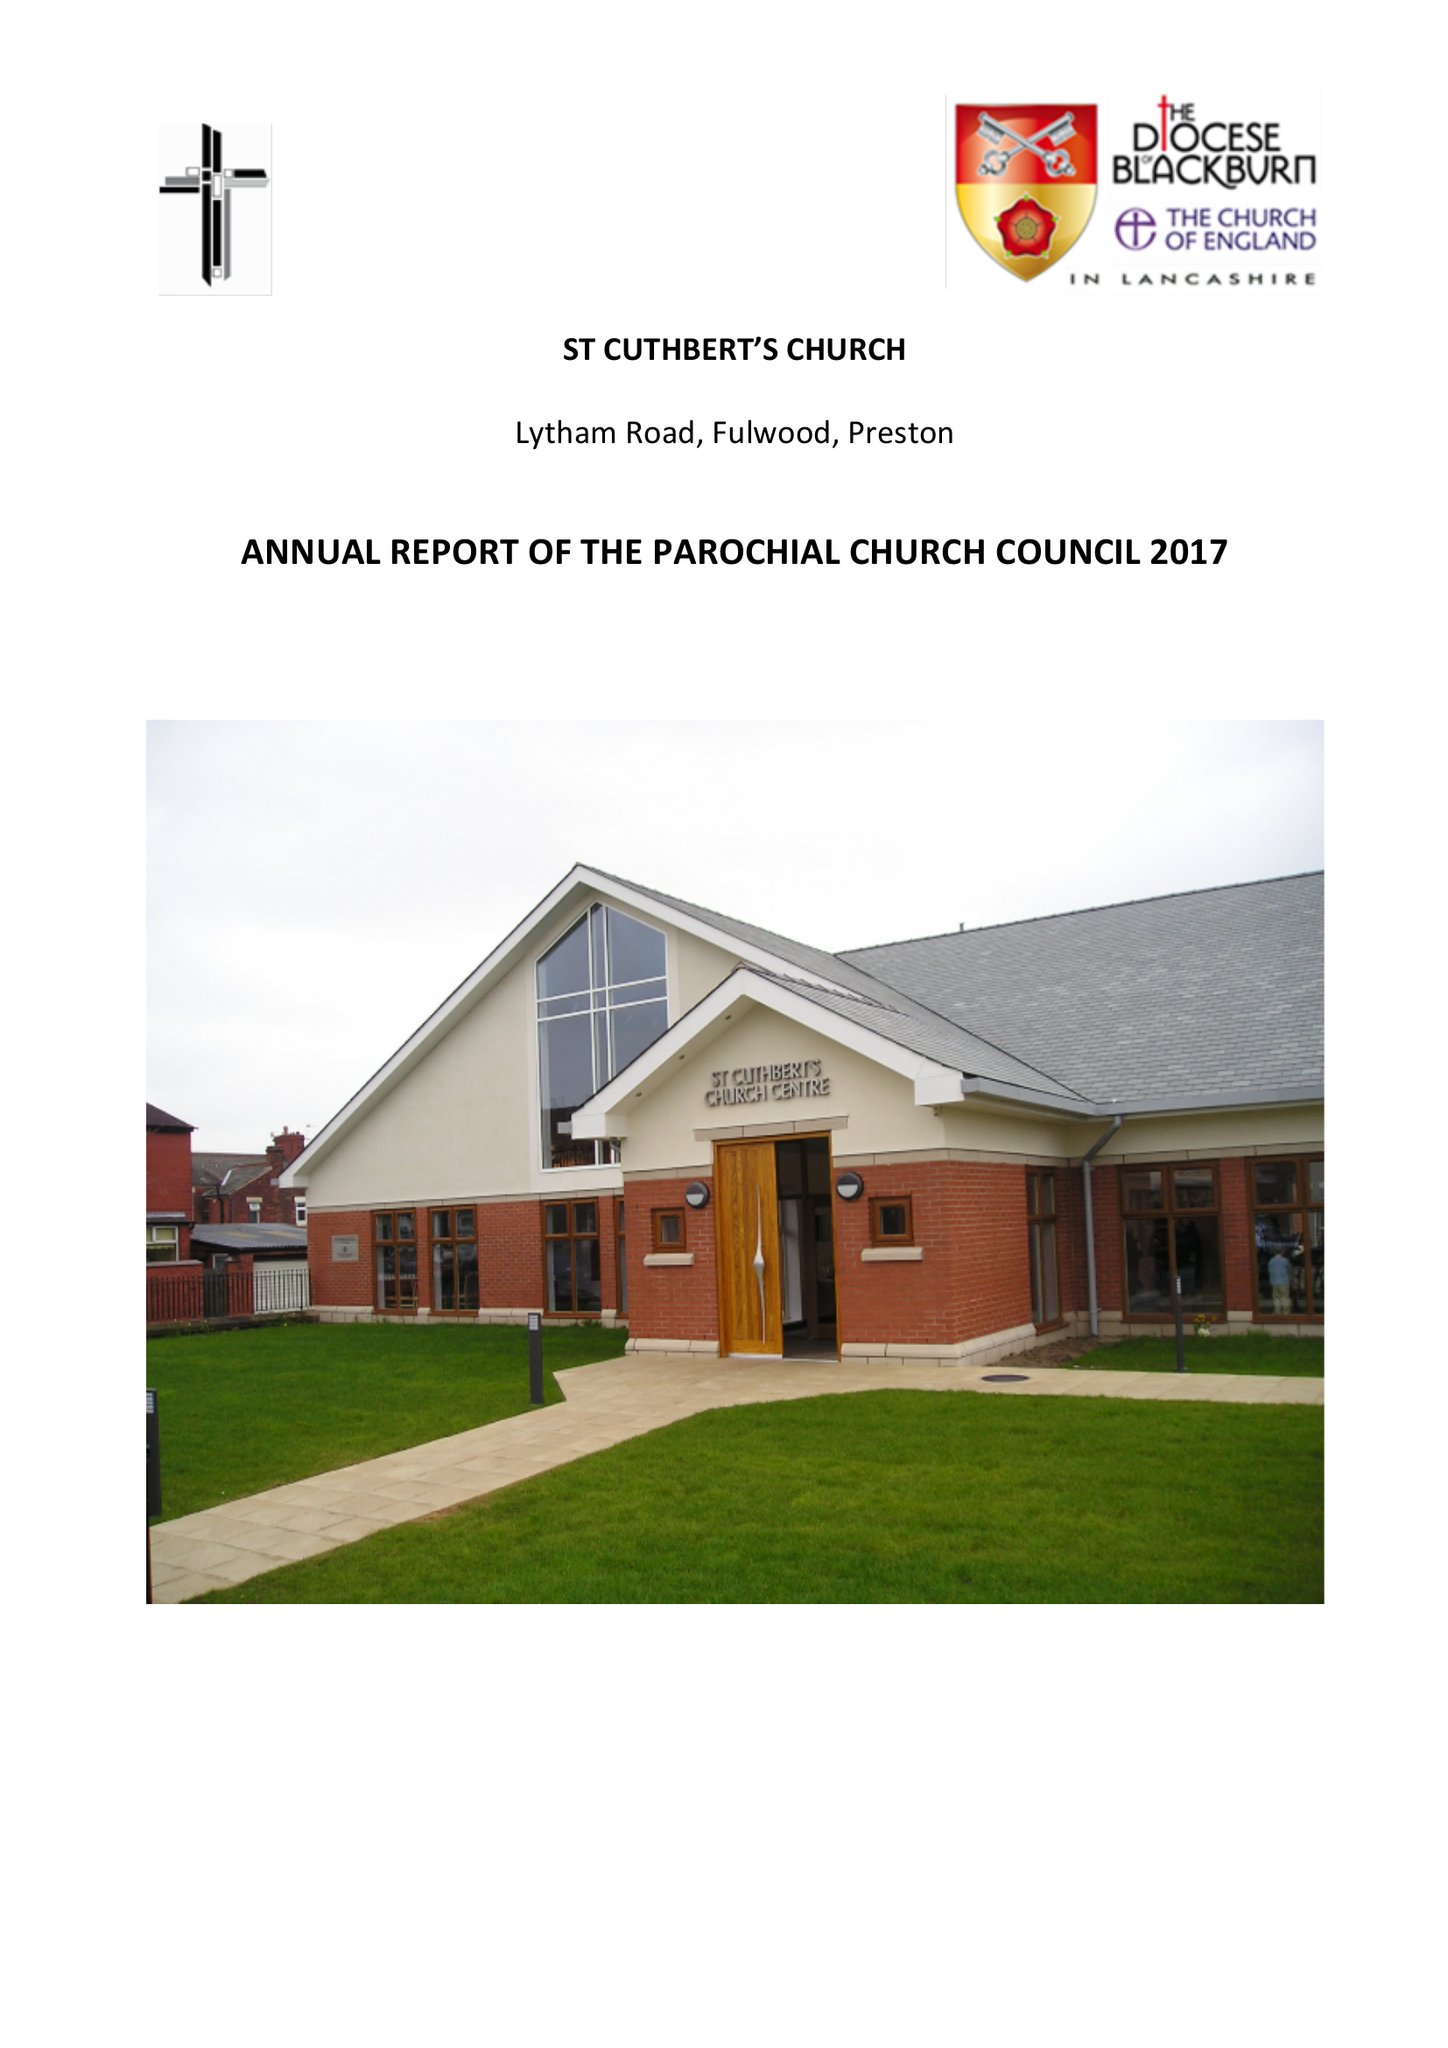What is the value for the address__postcode?
Answer the question using a single word or phrase. None 